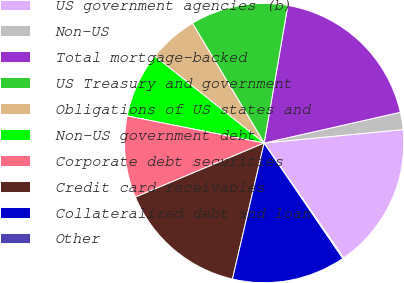Convert chart to OTSL. <chart><loc_0><loc_0><loc_500><loc_500><pie_chart><fcel>US government agencies (b)<fcel>Non-US<fcel>Total mortgage-backed<fcel>US Treasury and government<fcel>Obligations of US states and<fcel>Non-US government debt<fcel>Corporate debt securities<fcel>Credit card receivables<fcel>Collateralized debt and loan<fcel>Other<nl><fcel>16.89%<fcel>1.99%<fcel>18.75%<fcel>11.3%<fcel>5.72%<fcel>7.58%<fcel>9.44%<fcel>15.03%<fcel>13.17%<fcel>0.13%<nl></chart> 